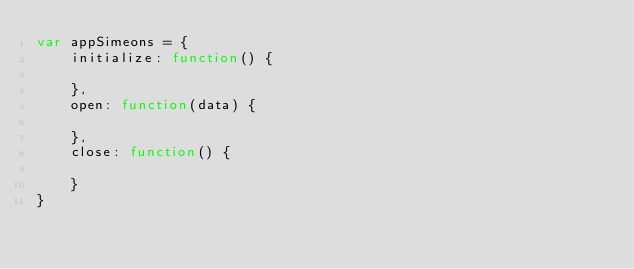Convert code to text. <code><loc_0><loc_0><loc_500><loc_500><_JavaScript_>var appSimeons = {
    initialize: function() {

    },
    open: function(data) {

    },
    close: function() {

    }
}</code> 